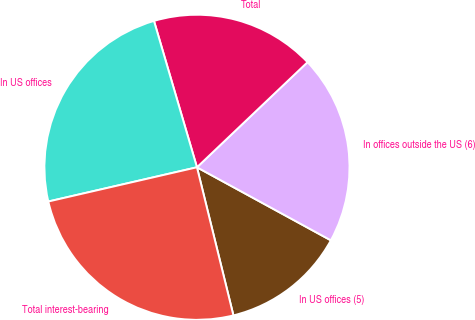Convert chart. <chart><loc_0><loc_0><loc_500><loc_500><pie_chart><fcel>In US offices (5)<fcel>In offices outside the US (6)<fcel>Total<fcel>In US offices<fcel>Total interest-bearing<nl><fcel>13.21%<fcel>20.05%<fcel>17.45%<fcel>24.06%<fcel>25.24%<nl></chart> 